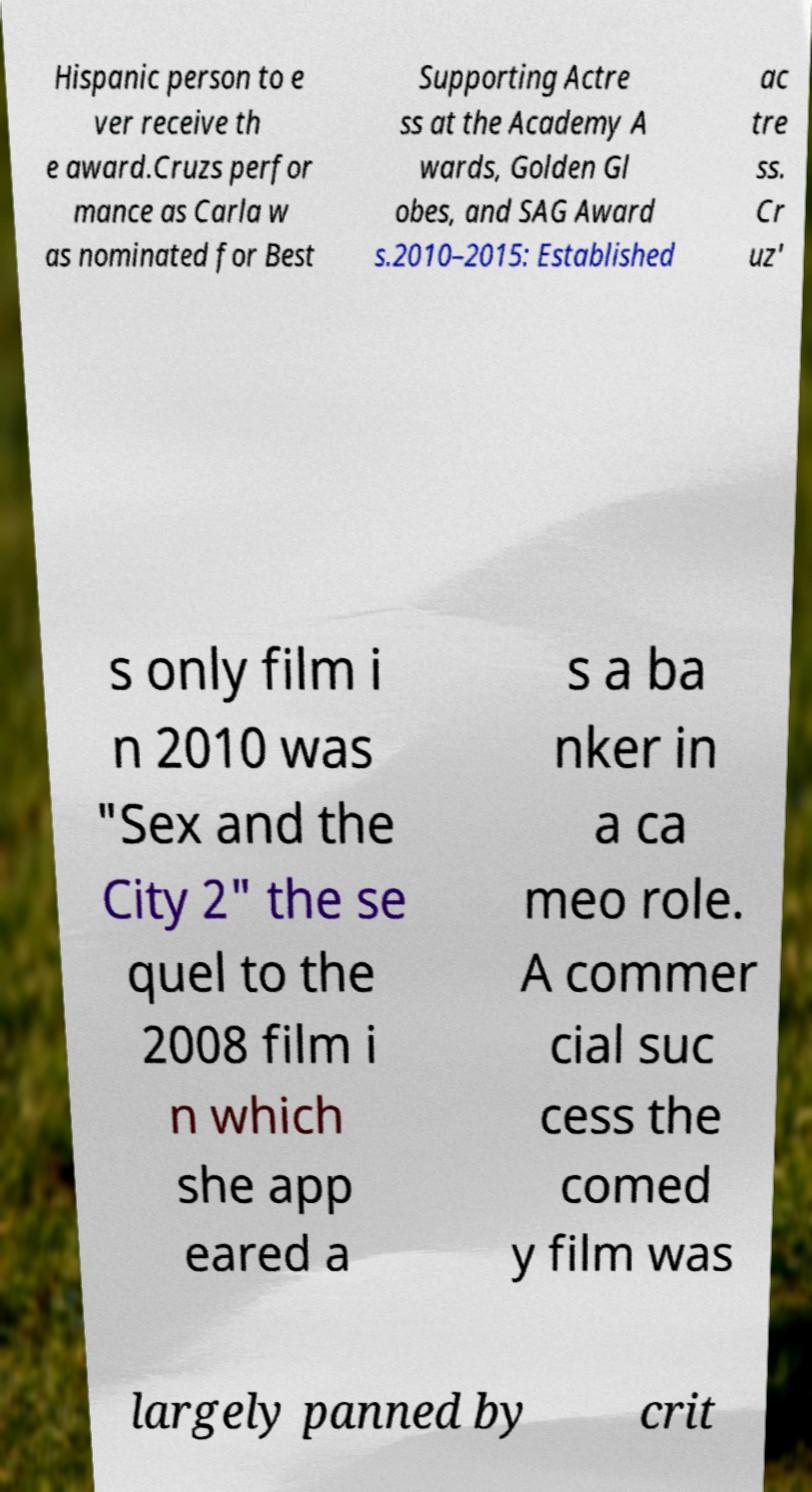Can you read and provide the text displayed in the image?This photo seems to have some interesting text. Can you extract and type it out for me? Hispanic person to e ver receive th e award.Cruzs perfor mance as Carla w as nominated for Best Supporting Actre ss at the Academy A wards, Golden Gl obes, and SAG Award s.2010–2015: Established ac tre ss. Cr uz' s only film i n 2010 was "Sex and the City 2" the se quel to the 2008 film i n which she app eared a s a ba nker in a ca meo role. A commer cial suc cess the comed y film was largely panned by crit 